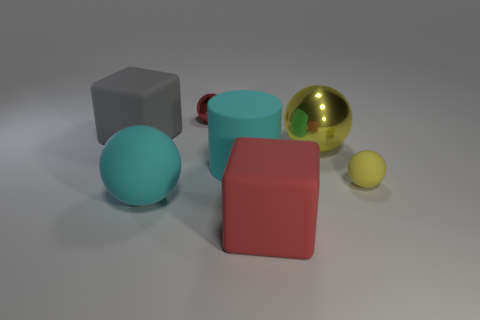Is the shape of the big object on the right side of the big red block the same as the shiny object that is behind the gray block?
Ensure brevity in your answer.  Yes. The large ball that is behind the small sphere that is to the right of the red thing that is right of the red sphere is what color?
Keep it short and to the point. Yellow. How many other objects are the same color as the tiny shiny thing?
Provide a short and direct response. 1. Is the number of things less than the number of small red balls?
Offer a terse response. No. There is a thing that is both left of the tiny red sphere and behind the big yellow metallic object; what color is it?
Ensure brevity in your answer.  Gray. There is a big cyan object that is the same shape as the red metallic object; what material is it?
Offer a terse response. Rubber. Is there any other thing that has the same size as the gray thing?
Provide a succinct answer. Yes. Is the number of big gray objects greater than the number of small purple matte balls?
Provide a short and direct response. Yes. How big is the rubber object that is behind the yellow matte sphere and right of the red metal object?
Keep it short and to the point. Large. There is a red shiny object; what shape is it?
Your answer should be very brief. Sphere. 